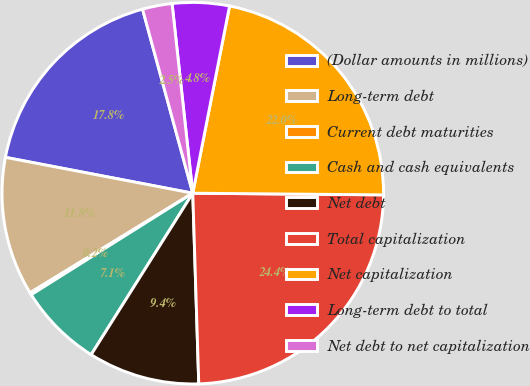<chart> <loc_0><loc_0><loc_500><loc_500><pie_chart><fcel>(Dollar amounts in millions)<fcel>Long-term debt<fcel>Current debt maturities<fcel>Cash and cash equivalents<fcel>Net debt<fcel>Total capitalization<fcel>Net capitalization<fcel>Long-term debt to total<fcel>Net debt to net capitalization<nl><fcel>17.75%<fcel>11.75%<fcel>0.19%<fcel>7.13%<fcel>9.44%<fcel>24.36%<fcel>22.05%<fcel>4.82%<fcel>2.51%<nl></chart> 